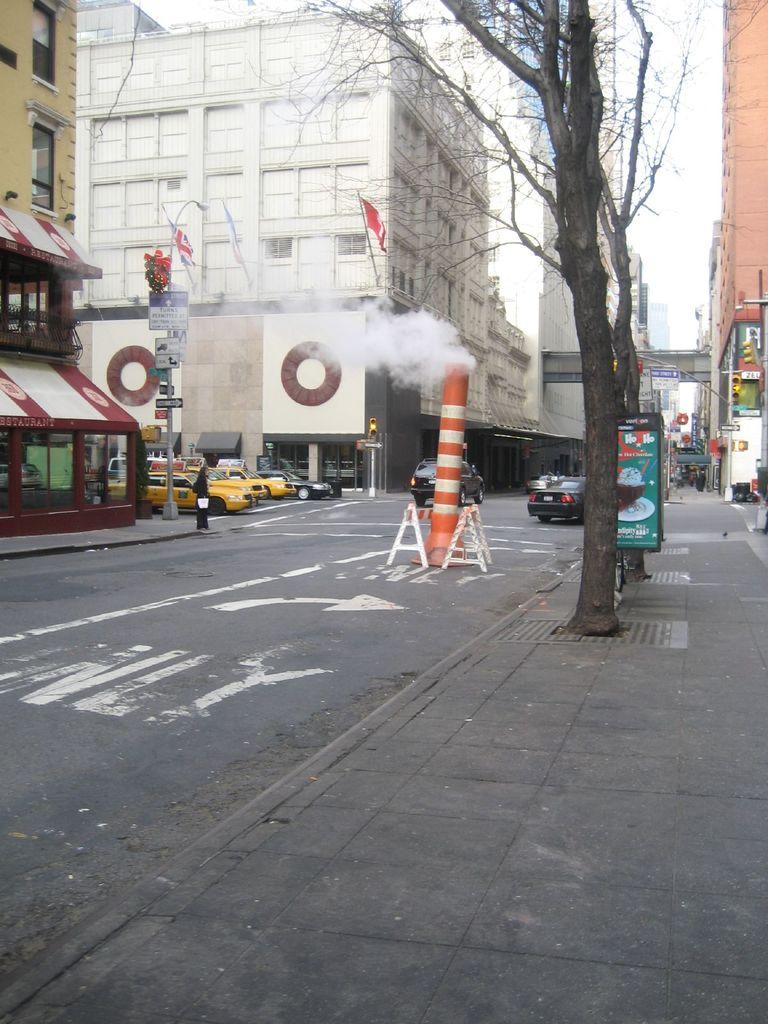What is happening on the road in the image? There are cars on a road in the image. What is present alongside the road? There is a footpath on either side of the road, and trees are also present on either side. What type of structures can be seen in the image? Buildings are visible in the image. Can you tell me what type of cap the person is wearing in the image? There is no person present in the image, so it is not possible to determine what type of cap they might be wearing. 